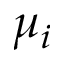Convert formula to latex. <formula><loc_0><loc_0><loc_500><loc_500>\mu _ { i }</formula> 